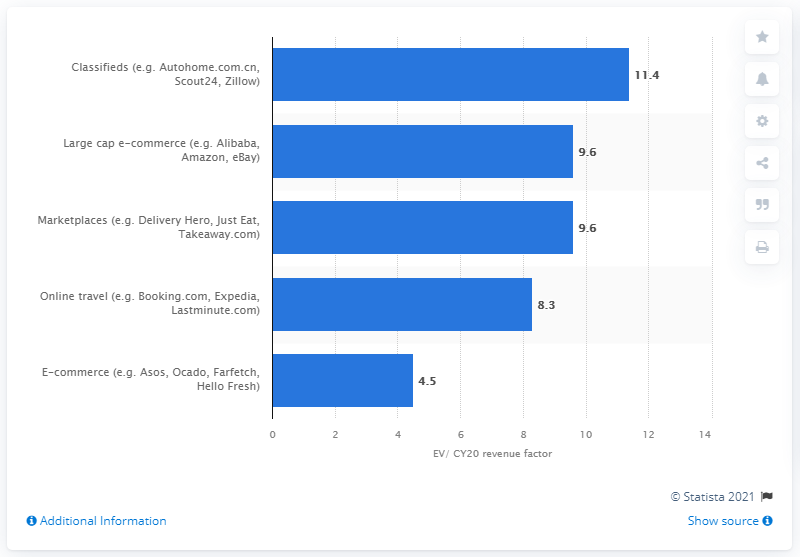Give some essential details in this illustration. The average Enterprise Value-to-Revenue (EV/R) of companies in the classifieds segment was 11.4. 